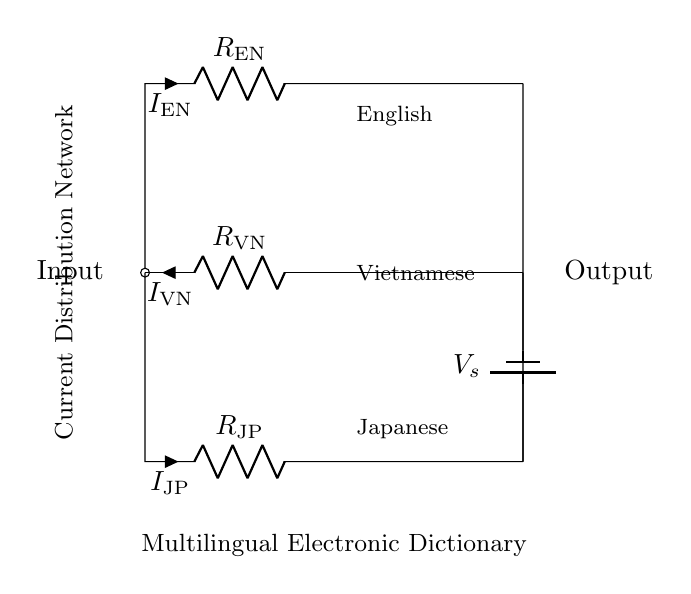What is the type of circuit shown? The circuit shown is a current divider, which splits input current into multiple paths.
Answer: Current divider What are the resistors in the circuit? The resistors present are R_EN, R_JP, and R_VN, corresponding to English, Japanese, and Vietnamese outputs.
Answer: R_EN, R_JP, R_VN How many current paths are there? There are three separate current paths for English, Japanese, and Vietnamese.
Answer: Three What is the input node of the circuit? The input node is located at the top left, where all branches connect.
Answer: Input node How is the output labeled in the diagram? The output is labeled on the right side, indicating the point where the currents recombine.
Answer: Output Which language corresponds to the current I_EN? The current I_EN corresponds to the English language output in the circuit.
Answer: English What happens to the total current in the current divider? The total input current is divided among the three resistors based on their resistance values.
Answer: Divided 